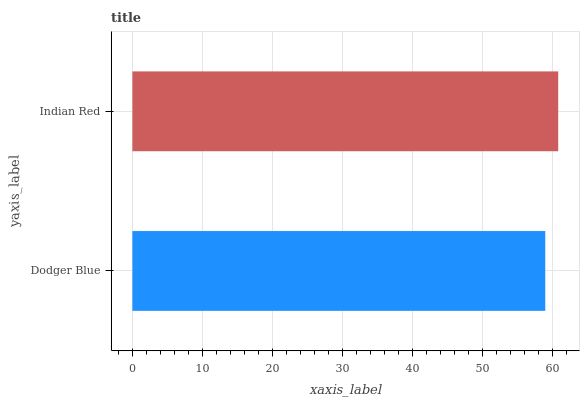Is Dodger Blue the minimum?
Answer yes or no. Yes. Is Indian Red the maximum?
Answer yes or no. Yes. Is Indian Red the minimum?
Answer yes or no. No. Is Indian Red greater than Dodger Blue?
Answer yes or no. Yes. Is Dodger Blue less than Indian Red?
Answer yes or no. Yes. Is Dodger Blue greater than Indian Red?
Answer yes or no. No. Is Indian Red less than Dodger Blue?
Answer yes or no. No. Is Indian Red the high median?
Answer yes or no. Yes. Is Dodger Blue the low median?
Answer yes or no. Yes. Is Dodger Blue the high median?
Answer yes or no. No. Is Indian Red the low median?
Answer yes or no. No. 